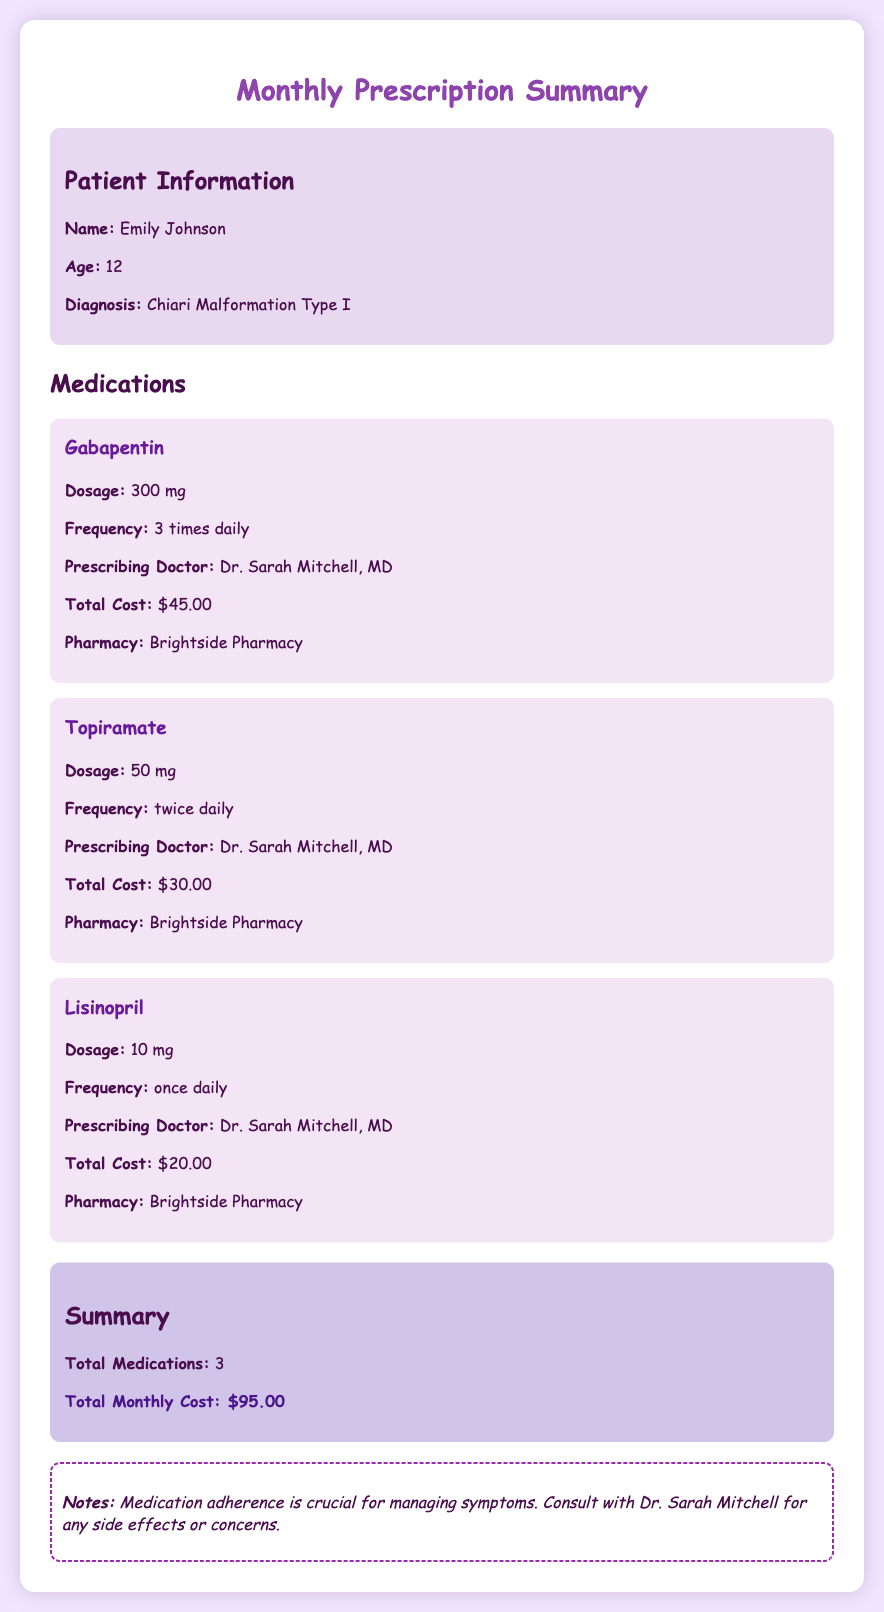What is the name of the patient? The document states the patient's name as Emily Johnson.
Answer: Emily Johnson How old is Emily? The document provides Emily's age as 12 years old.
Answer: 12 What is the total cost for Gabapentin? The document lists the total cost for Gabapentin as $45.00.
Answer: $45.00 How frequently should Topiramate be taken? The document specifies that Topiramate is to be taken twice daily.
Answer: twice daily Who is the prescribing doctor for all medications? The document indicates that the prescribing doctor for all medications is Dr. Sarah Mitchell, MD.
Answer: Dr. Sarah Mitchell, MD What is the total monthly cost for all medications? The document sums the costs of the medications, which is $95.00.
Answer: $95.00 What is the dosage of Lisinopril? The document provides the dosage of Lisinopril as 10 mg.
Answer: 10 mg What is noted about medication adherence? The document states that medication adherence is crucial for managing symptoms.
Answer: crucial for managing symptoms How many medications are listed in the summary? The document counts a total of 3 medications.
Answer: 3 